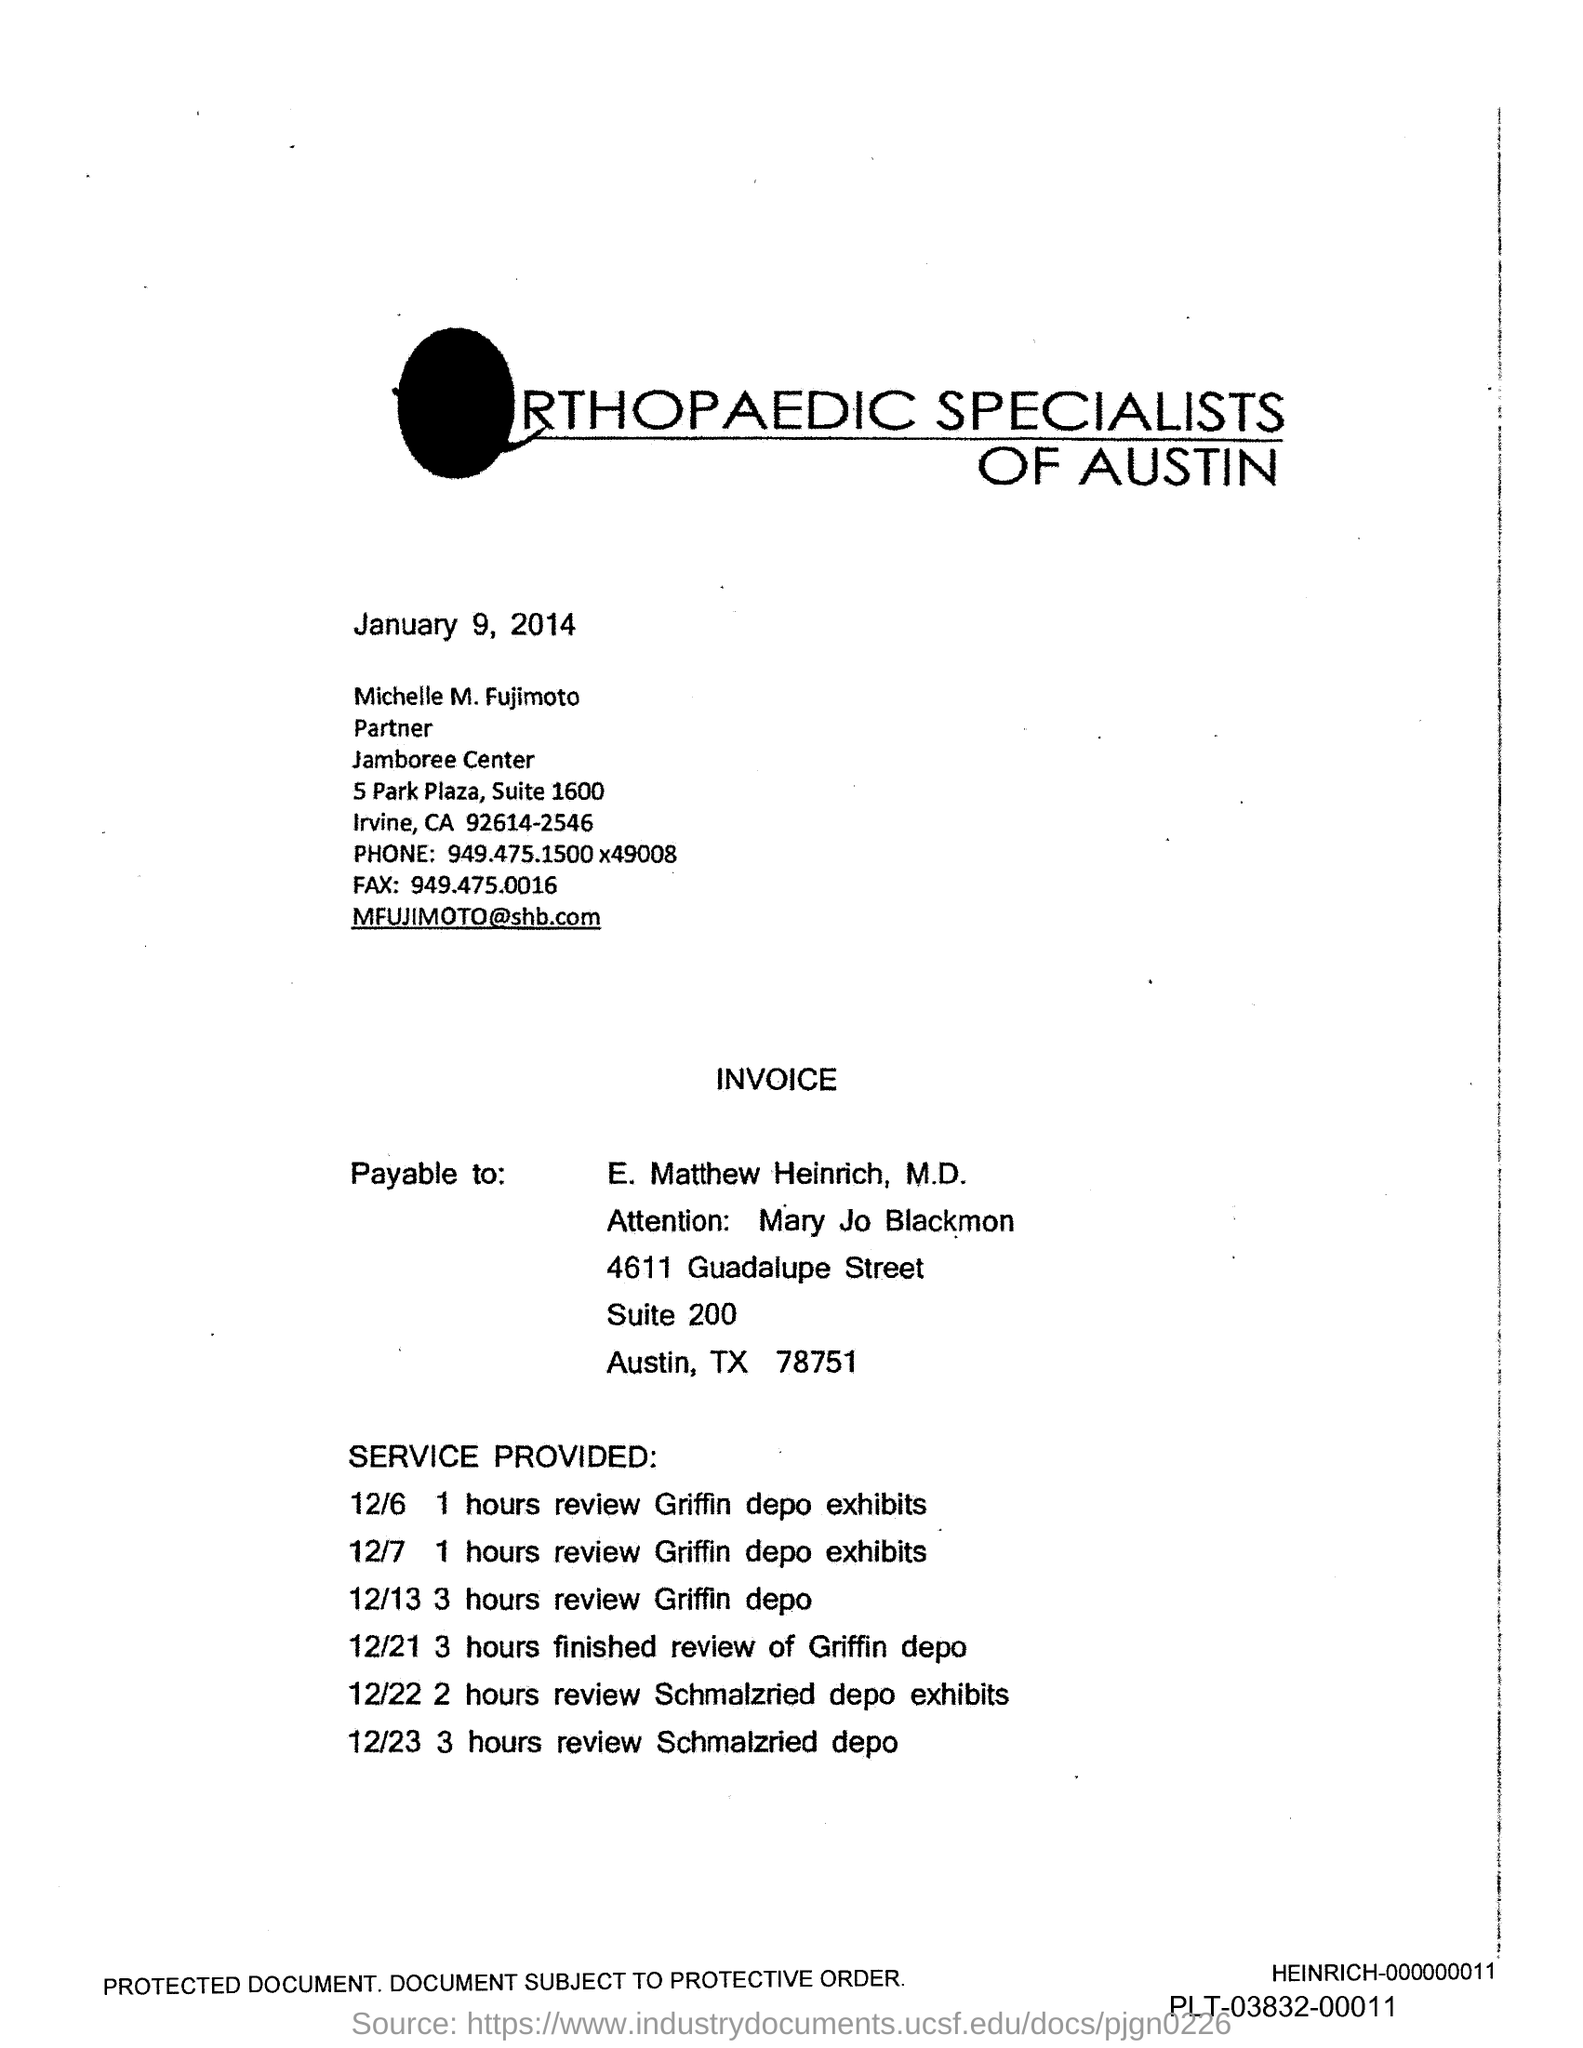What is the Fax number?
Your answer should be very brief. 949.475.0016. 